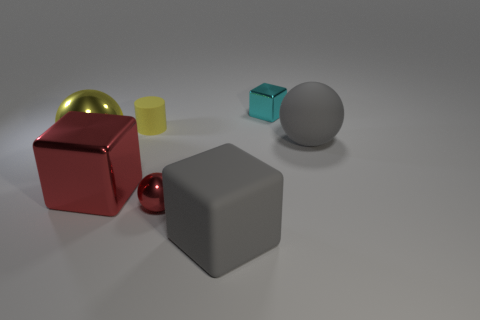Is the color of the tiny cylinder the same as the big metallic ball?
Your answer should be compact. Yes. There is a red shiny object that is the same shape as the big yellow object; what size is it?
Your answer should be very brief. Small. How many yellow cylinders are the same size as the yellow shiny sphere?
Provide a succinct answer. 0. What material is the red cube?
Provide a short and direct response. Metal. There is a small yellow object; are there any small objects on the right side of it?
Offer a terse response. Yes. There is a sphere that is made of the same material as the cylinder; what is its size?
Provide a short and direct response. Large. How many tiny shiny blocks have the same color as the big shiny sphere?
Your response must be concise. 0. Are there fewer small yellow things that are in front of the big gray matte ball than objects in front of the rubber cylinder?
Provide a short and direct response. Yes. How big is the rubber thing that is left of the red sphere?
Keep it short and to the point. Small. What size is the matte cylinder that is the same color as the large shiny sphere?
Make the answer very short. Small. 